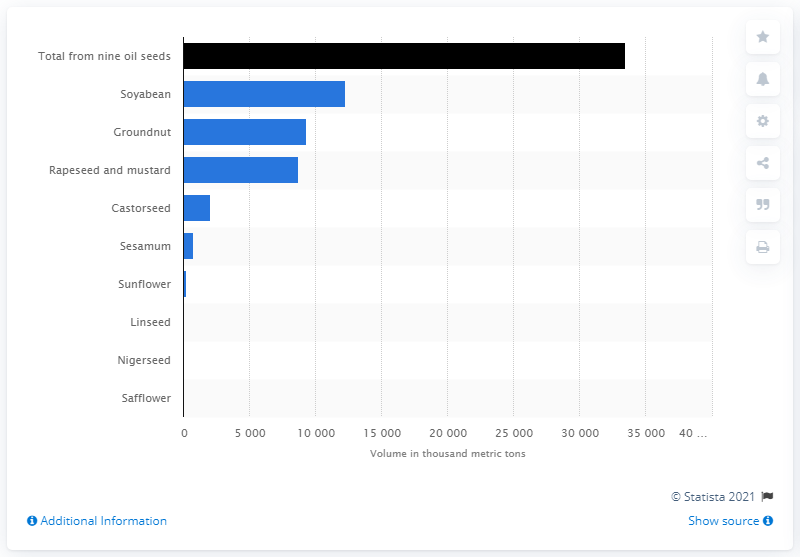Give some essential details in this illustration. According to the latest statistics, the highest produced oilseed in India in 2020 was soyabean. 